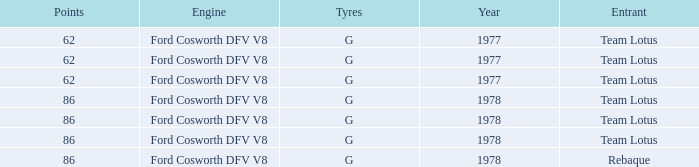Would you mind parsing the complete table? {'header': ['Points', 'Engine', 'Tyres', 'Year', 'Entrant'], 'rows': [['62', 'Ford Cosworth DFV V8', 'G', '1977', 'Team Lotus'], ['62', 'Ford Cosworth DFV V8', 'G', '1977', 'Team Lotus'], ['62', 'Ford Cosworth DFV V8', 'G', '1977', 'Team Lotus'], ['86', 'Ford Cosworth DFV V8', 'G', '1978', 'Team Lotus'], ['86', 'Ford Cosworth DFV V8', 'G', '1978', 'Team Lotus'], ['86', 'Ford Cosworth DFV V8', 'G', '1978', 'Team Lotus'], ['86', 'Ford Cosworth DFV V8', 'G', '1978', 'Rebaque']]} What is the Focus that has a Year bigger than 1977? 86, 86, 86, 86. 